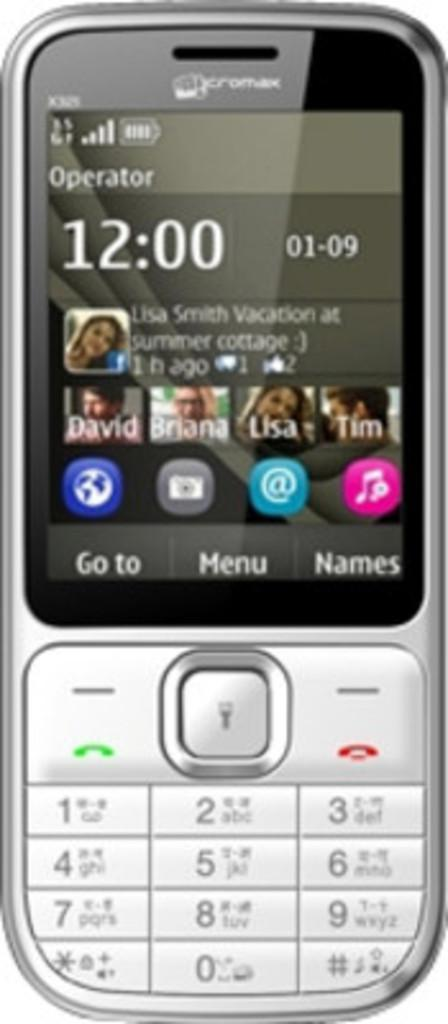<image>
Relay a brief, clear account of the picture shown. A Crotink brand cell phone showing it to be twelve o clock. 